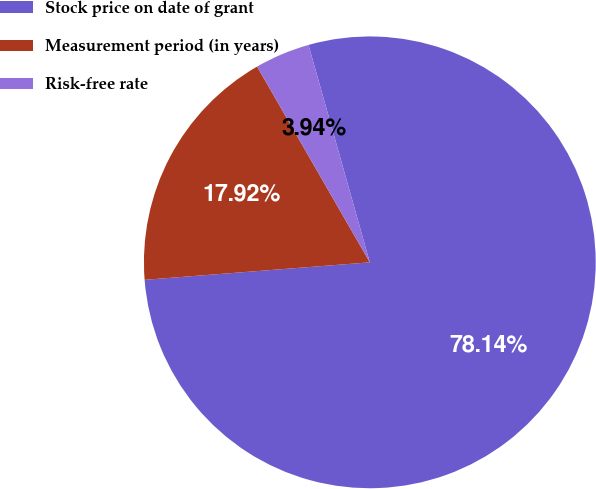<chart> <loc_0><loc_0><loc_500><loc_500><pie_chart><fcel>Stock price on date of grant<fcel>Measurement period (in years)<fcel>Risk-free rate<nl><fcel>78.14%<fcel>17.92%<fcel>3.94%<nl></chart> 